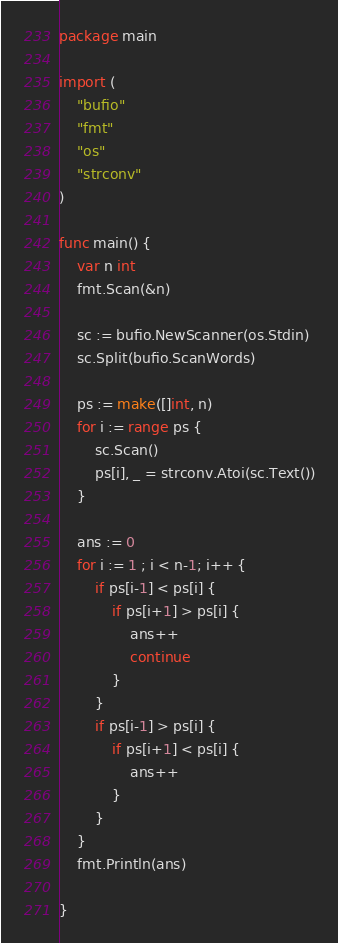Convert code to text. <code><loc_0><loc_0><loc_500><loc_500><_Go_>package main

import (
	"bufio"
	"fmt"
	"os"
	"strconv"
)

func main() {
	var n int
	fmt.Scan(&n)

	sc := bufio.NewScanner(os.Stdin)
	sc.Split(bufio.ScanWords)

	ps := make([]int, n)
	for i := range ps {
		sc.Scan()
		ps[i], _ = strconv.Atoi(sc.Text())
	}

	ans := 0
	for i := 1 ; i < n-1; i++ {
		if ps[i-1] < ps[i] {
			if ps[i+1] > ps[i] {
				ans++
				continue
			}
		}
		if ps[i-1] > ps[i] {
			if ps[i+1] < ps[i] {
				ans++
			}
		}
	}
	fmt.Println(ans)

}
</code> 